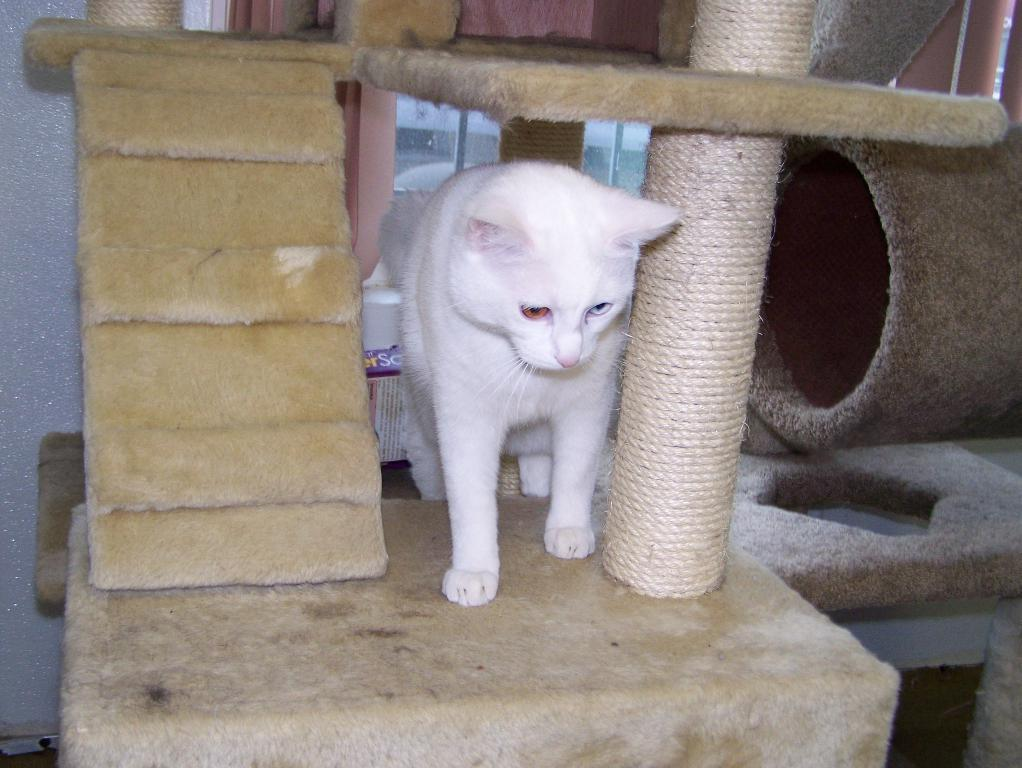What animal is present in the image? There is a cat in the image. Where is the cat located? The cat is on a cat house. What can be seen on the right side of the image? There are objects on the right side of the image. What is visible in the background of the image? There is a glass window in the background of the image. What type of basin is being used to make a request in the image? There is no basin or request present in the image; it features a cat on a cat house and objects on the right side of the image. 